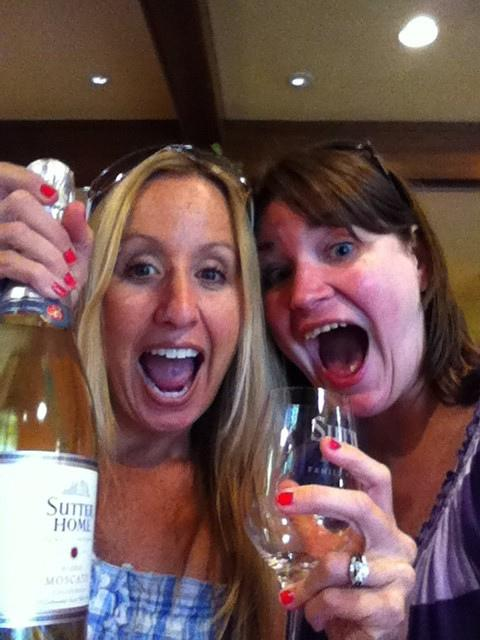What emotion are the woman exhibiting?

Choices:
A) joyful
B) surprised
C) scared
D) fearful joyful 